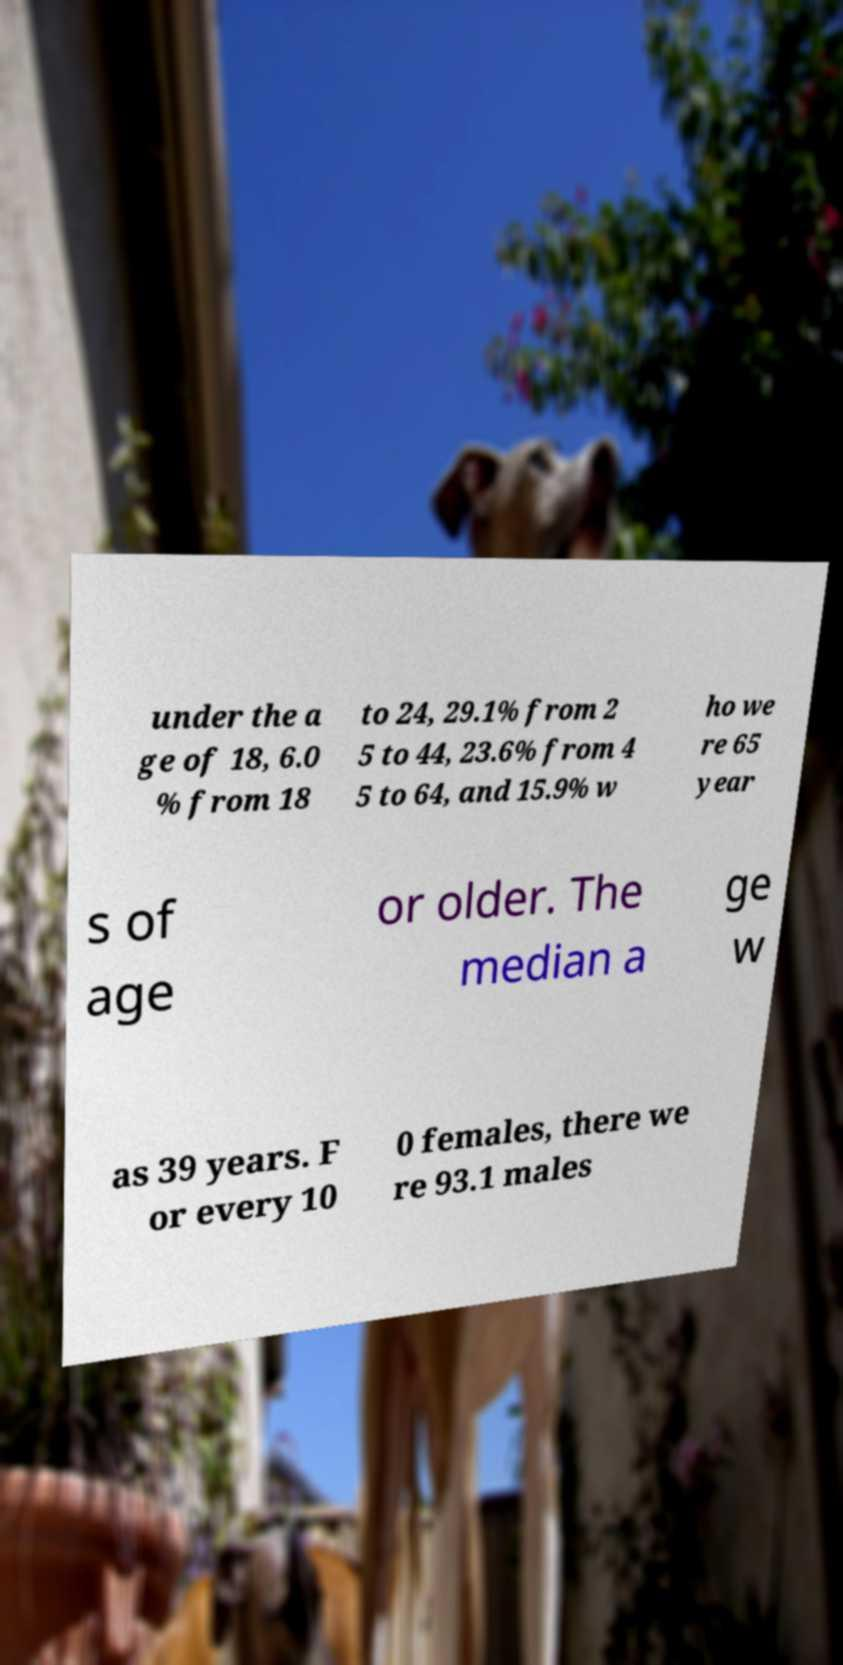Could you extract and type out the text from this image? under the a ge of 18, 6.0 % from 18 to 24, 29.1% from 2 5 to 44, 23.6% from 4 5 to 64, and 15.9% w ho we re 65 year s of age or older. The median a ge w as 39 years. F or every 10 0 females, there we re 93.1 males 